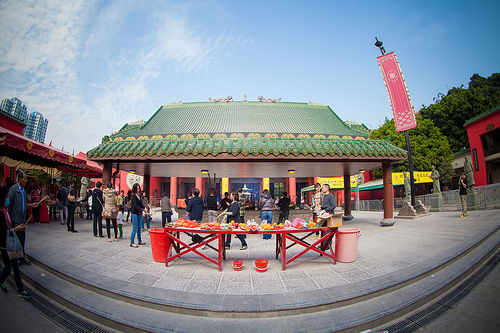<image>
Is there a roof behind the woman? Yes. From this viewpoint, the roof is positioned behind the woman, with the woman partially or fully occluding the roof. 